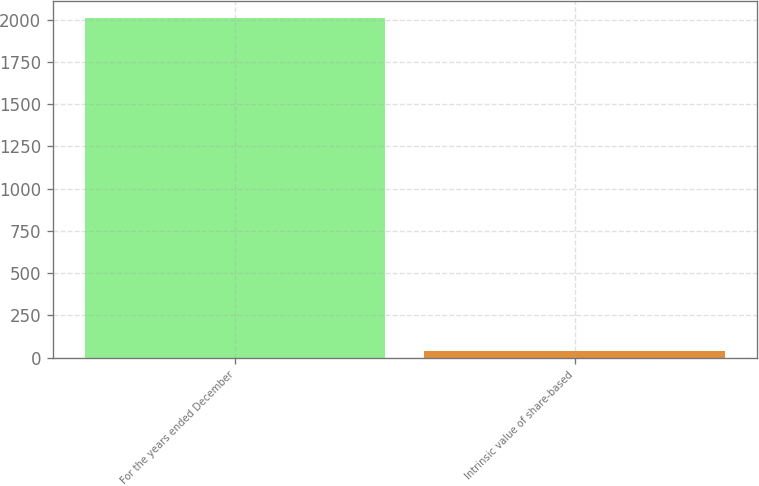<chart> <loc_0><loc_0><loc_500><loc_500><bar_chart><fcel>For the years ended December<fcel>Intrinsic value of share-based<nl><fcel>2011<fcel>36.6<nl></chart> 